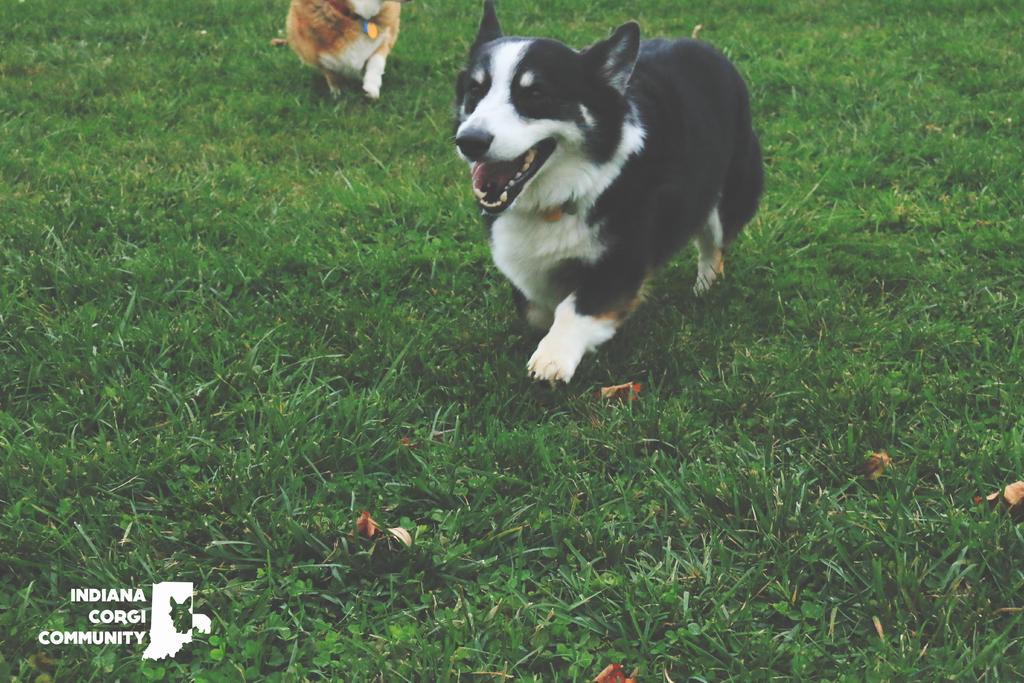What type of animal is present in the image? There is a dog in the image. What is the dog doing in the image? The dog is running on the grass. What can be seen at the top of the image? There is an animal visible at the top of the image. What elements are present on the left side bottom of the image? There is a watermark and an icon on the left side bottom of the image. What historical event is depicted in the image? There is no historical event depicted in the image; it features a dog running on the grass. Can you tell me how many times the donkey rolls in the image? There is no donkey present in the image, so it is not possible to determine how many times it might roll. 